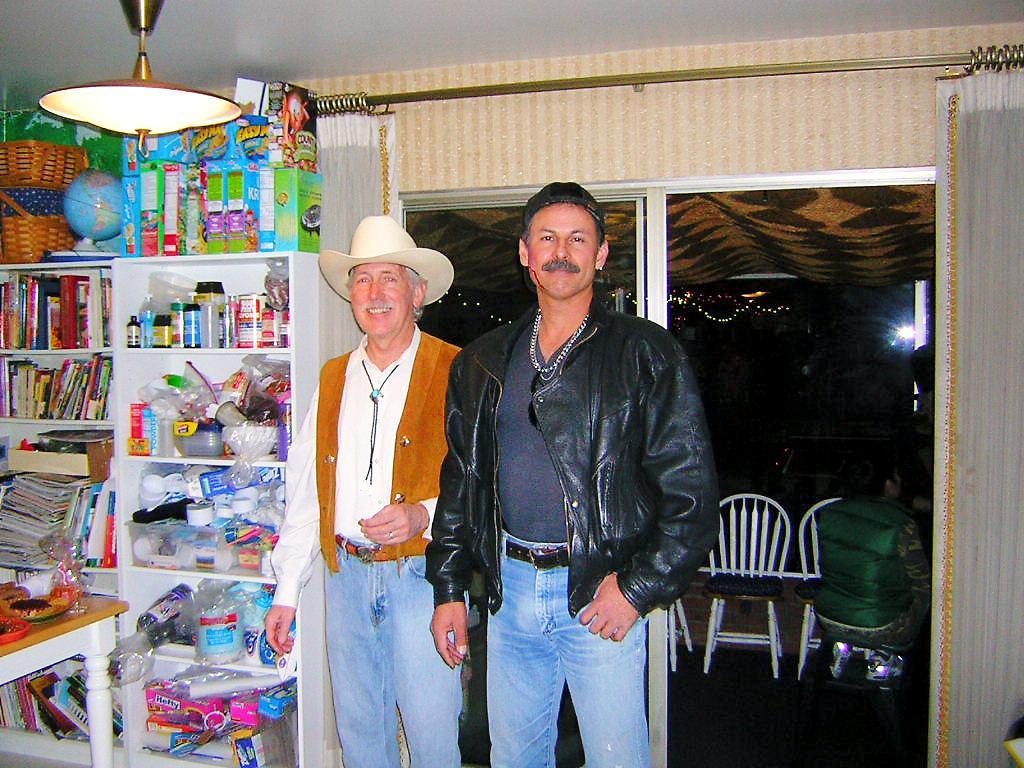Could you give a brief overview of what you see in this image? In this picture there are two men standing and there is a light attached to the roof. We also observe a window in the background. 